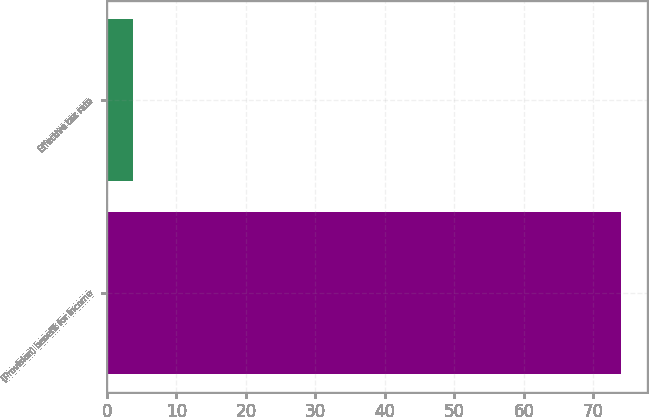<chart> <loc_0><loc_0><loc_500><loc_500><bar_chart><fcel>(Provision) benefit for income<fcel>Effective tax rate<nl><fcel>74<fcel>3.8<nl></chart> 